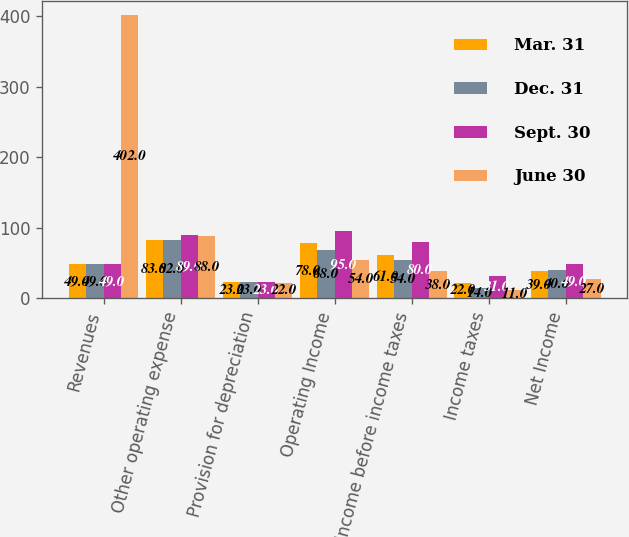Convert chart. <chart><loc_0><loc_0><loc_500><loc_500><stacked_bar_chart><ecel><fcel>Revenues<fcel>Other operating expense<fcel>Provision for depreciation<fcel>Operating Income<fcel>Income before income taxes<fcel>Income taxes<fcel>Net Income<nl><fcel>Mar. 31<fcel>49<fcel>83<fcel>23<fcel>78<fcel>61<fcel>22<fcel>39<nl><fcel>Dec. 31<fcel>49<fcel>82<fcel>23<fcel>68<fcel>54<fcel>14<fcel>40<nl><fcel>Sept. 30<fcel>49<fcel>89<fcel>23<fcel>95<fcel>80<fcel>31<fcel>49<nl><fcel>June 30<fcel>402<fcel>88<fcel>22<fcel>54<fcel>38<fcel>11<fcel>27<nl></chart> 